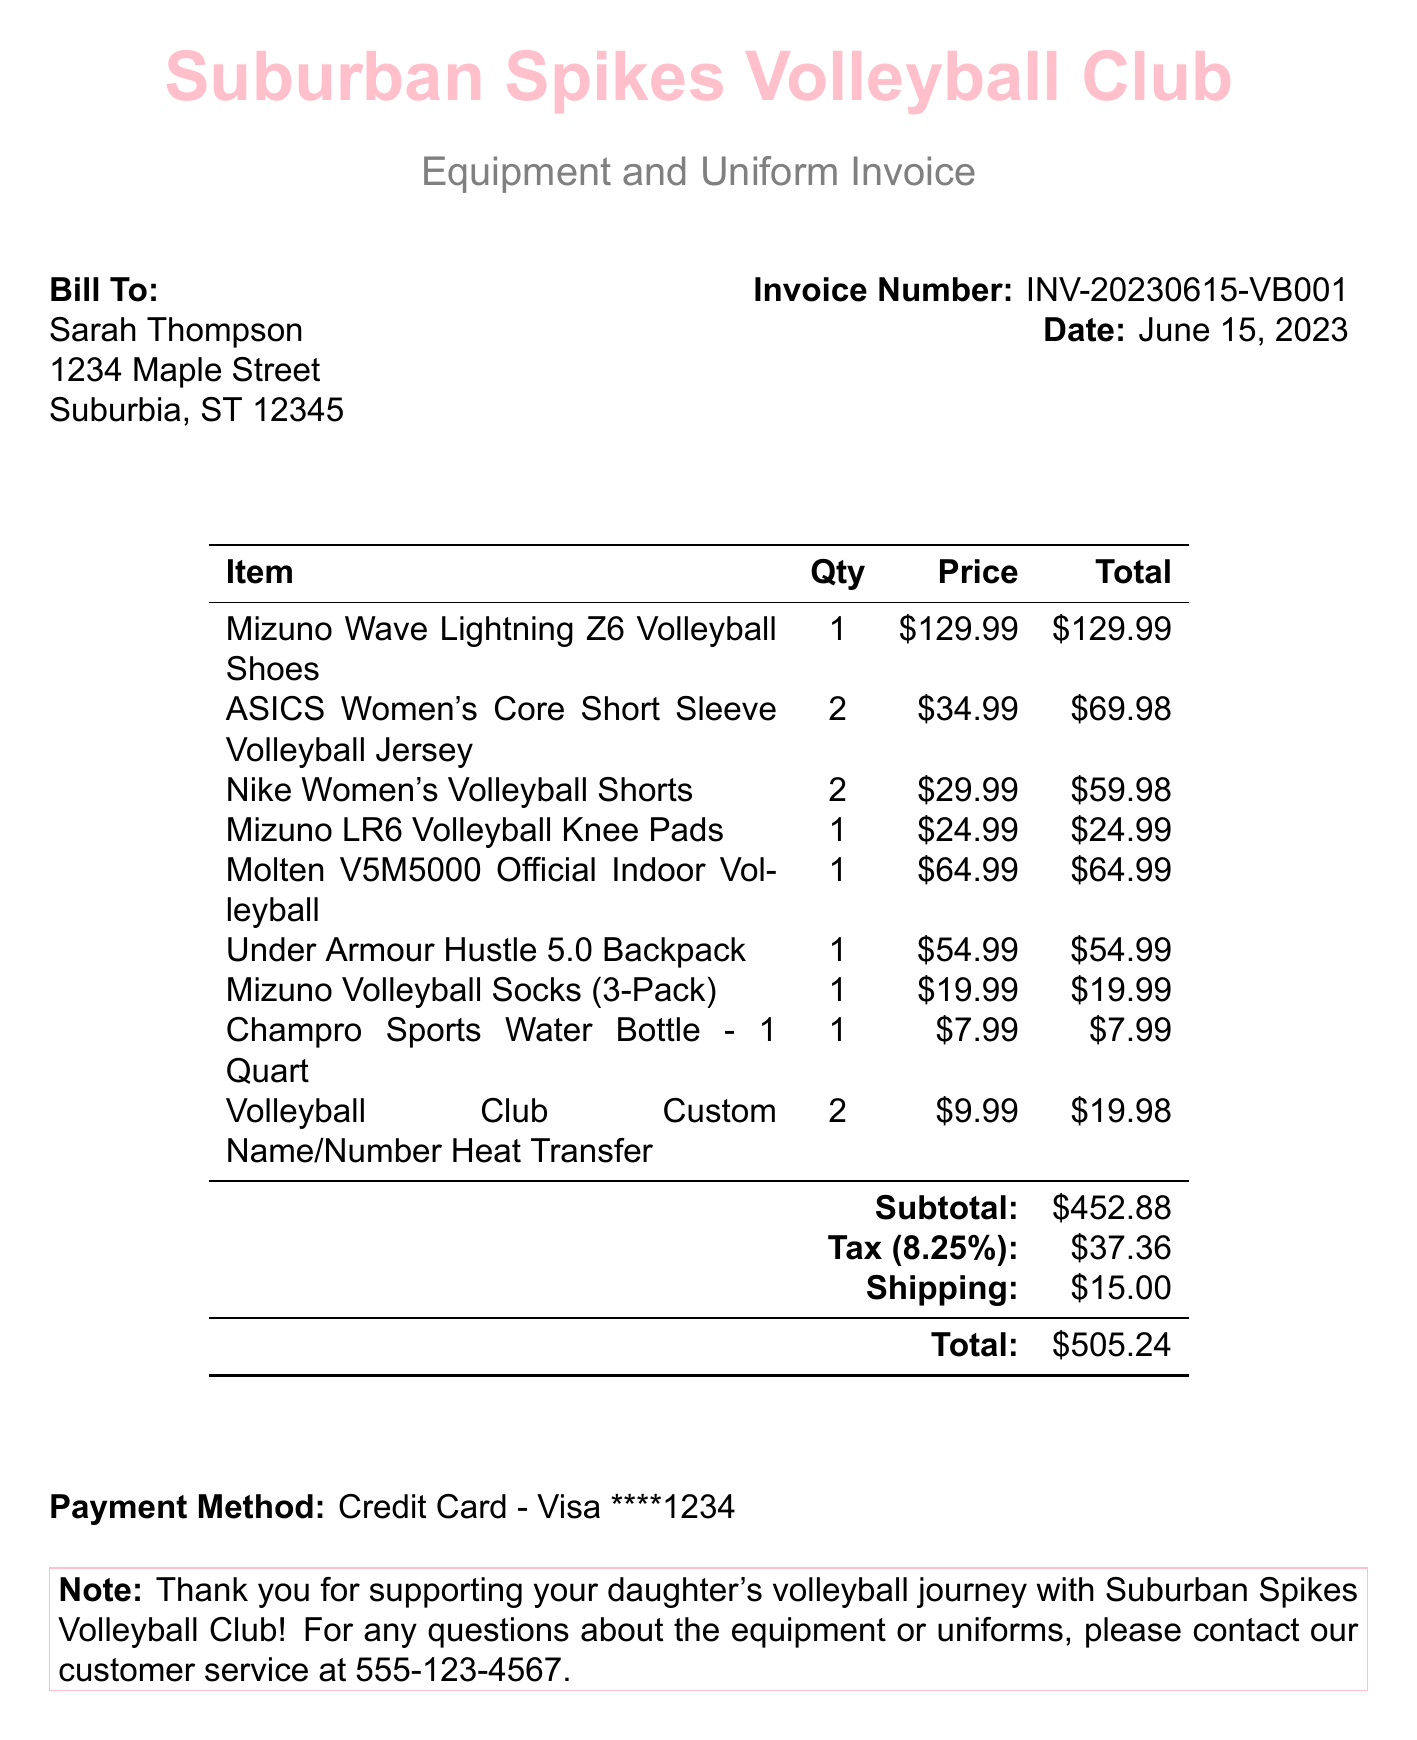What is the invoice number? The invoice number is located near the top right of the document.
Answer: INV-20230615-VB001 What items are listed in the invoice? The item names can be found in the item description section of the document.
Answer: Mizuno Wave Lightning Z6 Volleyball Shoes, ASICS Women's Core Short Sleeve Volleyball Jersey, Nike Women's Volleyball Shorts, Mizuno LR6 Volleyball Knee Pads, Molten V5M5000 Official Indoor Volleyball, Under Armour Hustle 5.0 Backpack, Mizuno Volleyball Socks (3-Pack), Champro Sports Water Bottle - 1 Quart, Volleyball Club Custom Name/Number Heat Transfer What is the subtotal amount? The subtotal is listed before tax and shipping in the invoice summary.
Answer: $452.88 How much tax was charged? The tax amount is provided under the tax section of the invoice.
Answer: $37.36 What is the total due? The total due is the final amount summarized at the end of the invoice.
Answer: $505.24 How many ASICS Women's Core Short Sleeve Volleyball Jerseys were purchased? The quantity of the jerseys is listed next to the item on the invoice.
Answer: 2 What payment method was used? The payment method is mentioned toward the bottom of the invoice.
Answer: Credit Card - Visa ****1234 What address is the invoice billed to? The billing address is presented in the "Bill To" section at the top of the document.
Answer: 1234 Maple Street, Suburbia, ST 12345 What does the note at the end of the invoice say? The note provides customer appreciation and contact information, located at the bottom.
Answer: Thank you for supporting your daughter's volleyball journey with Suburban Spikes Volleyball Club! For any questions about the equipment or uniforms, please contact our customer service at 555-123-4567 